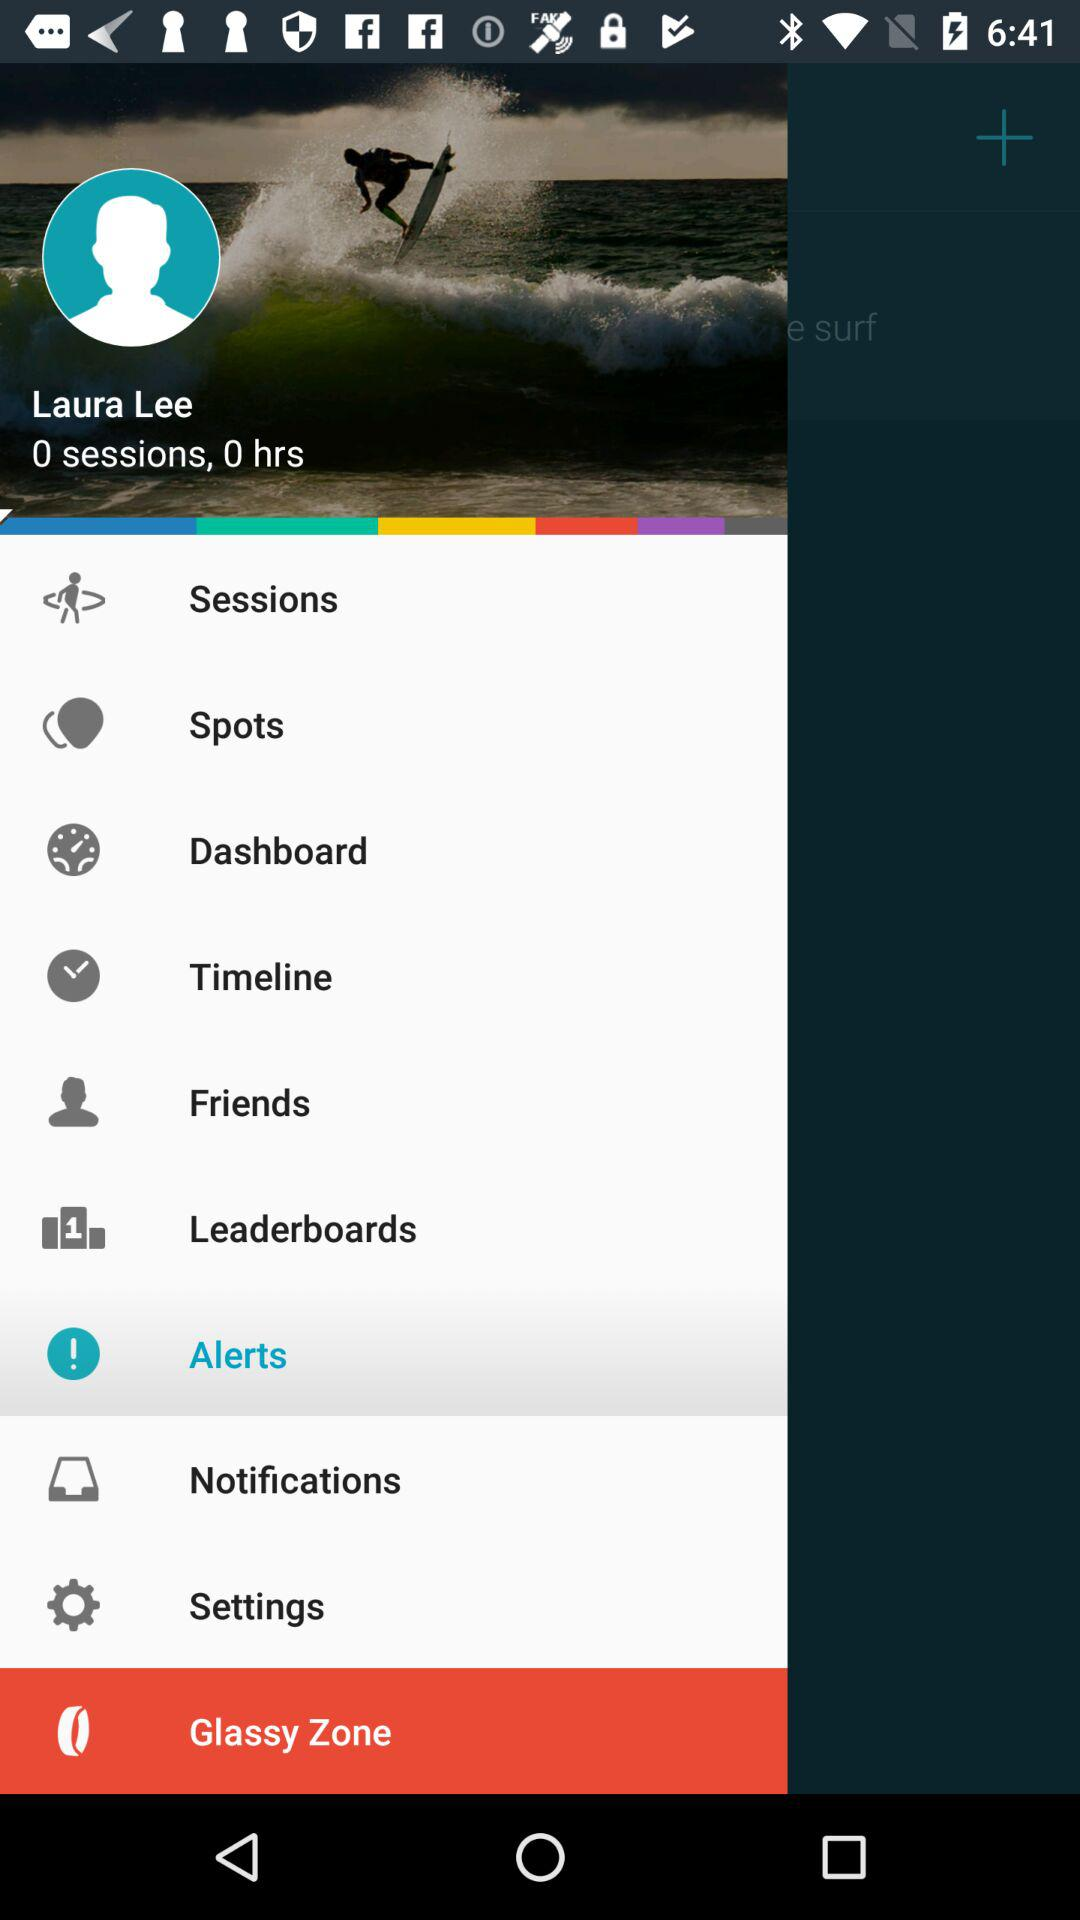How many sessions are there? There are zero sessions. 